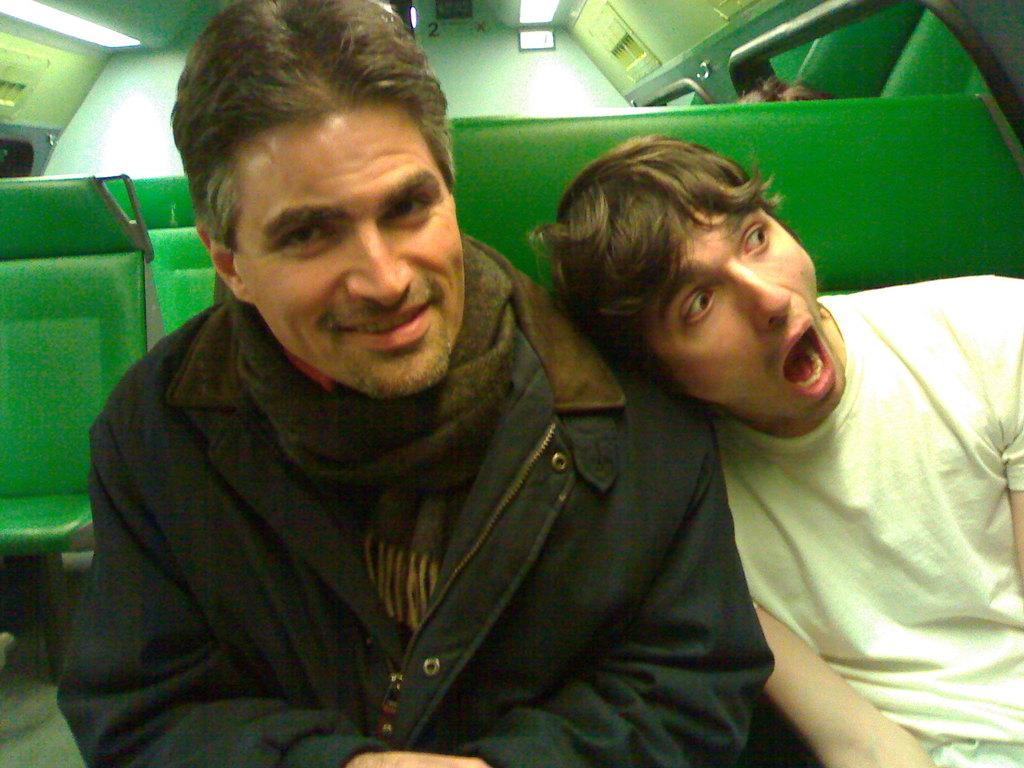How many people are in the image? There are two persons in the image. What are the two persons doing in the image? The two persons are sitting. Where are the two persons located in the image? The two persons are inside a train in the image? What type of feather can be seen on the person's hat in the image? There is no feather present on any person's hat in the image. Can you describe the bath that the persons are taking in the image? There is no bath present in the image; the two persons are sitting inside a train. 